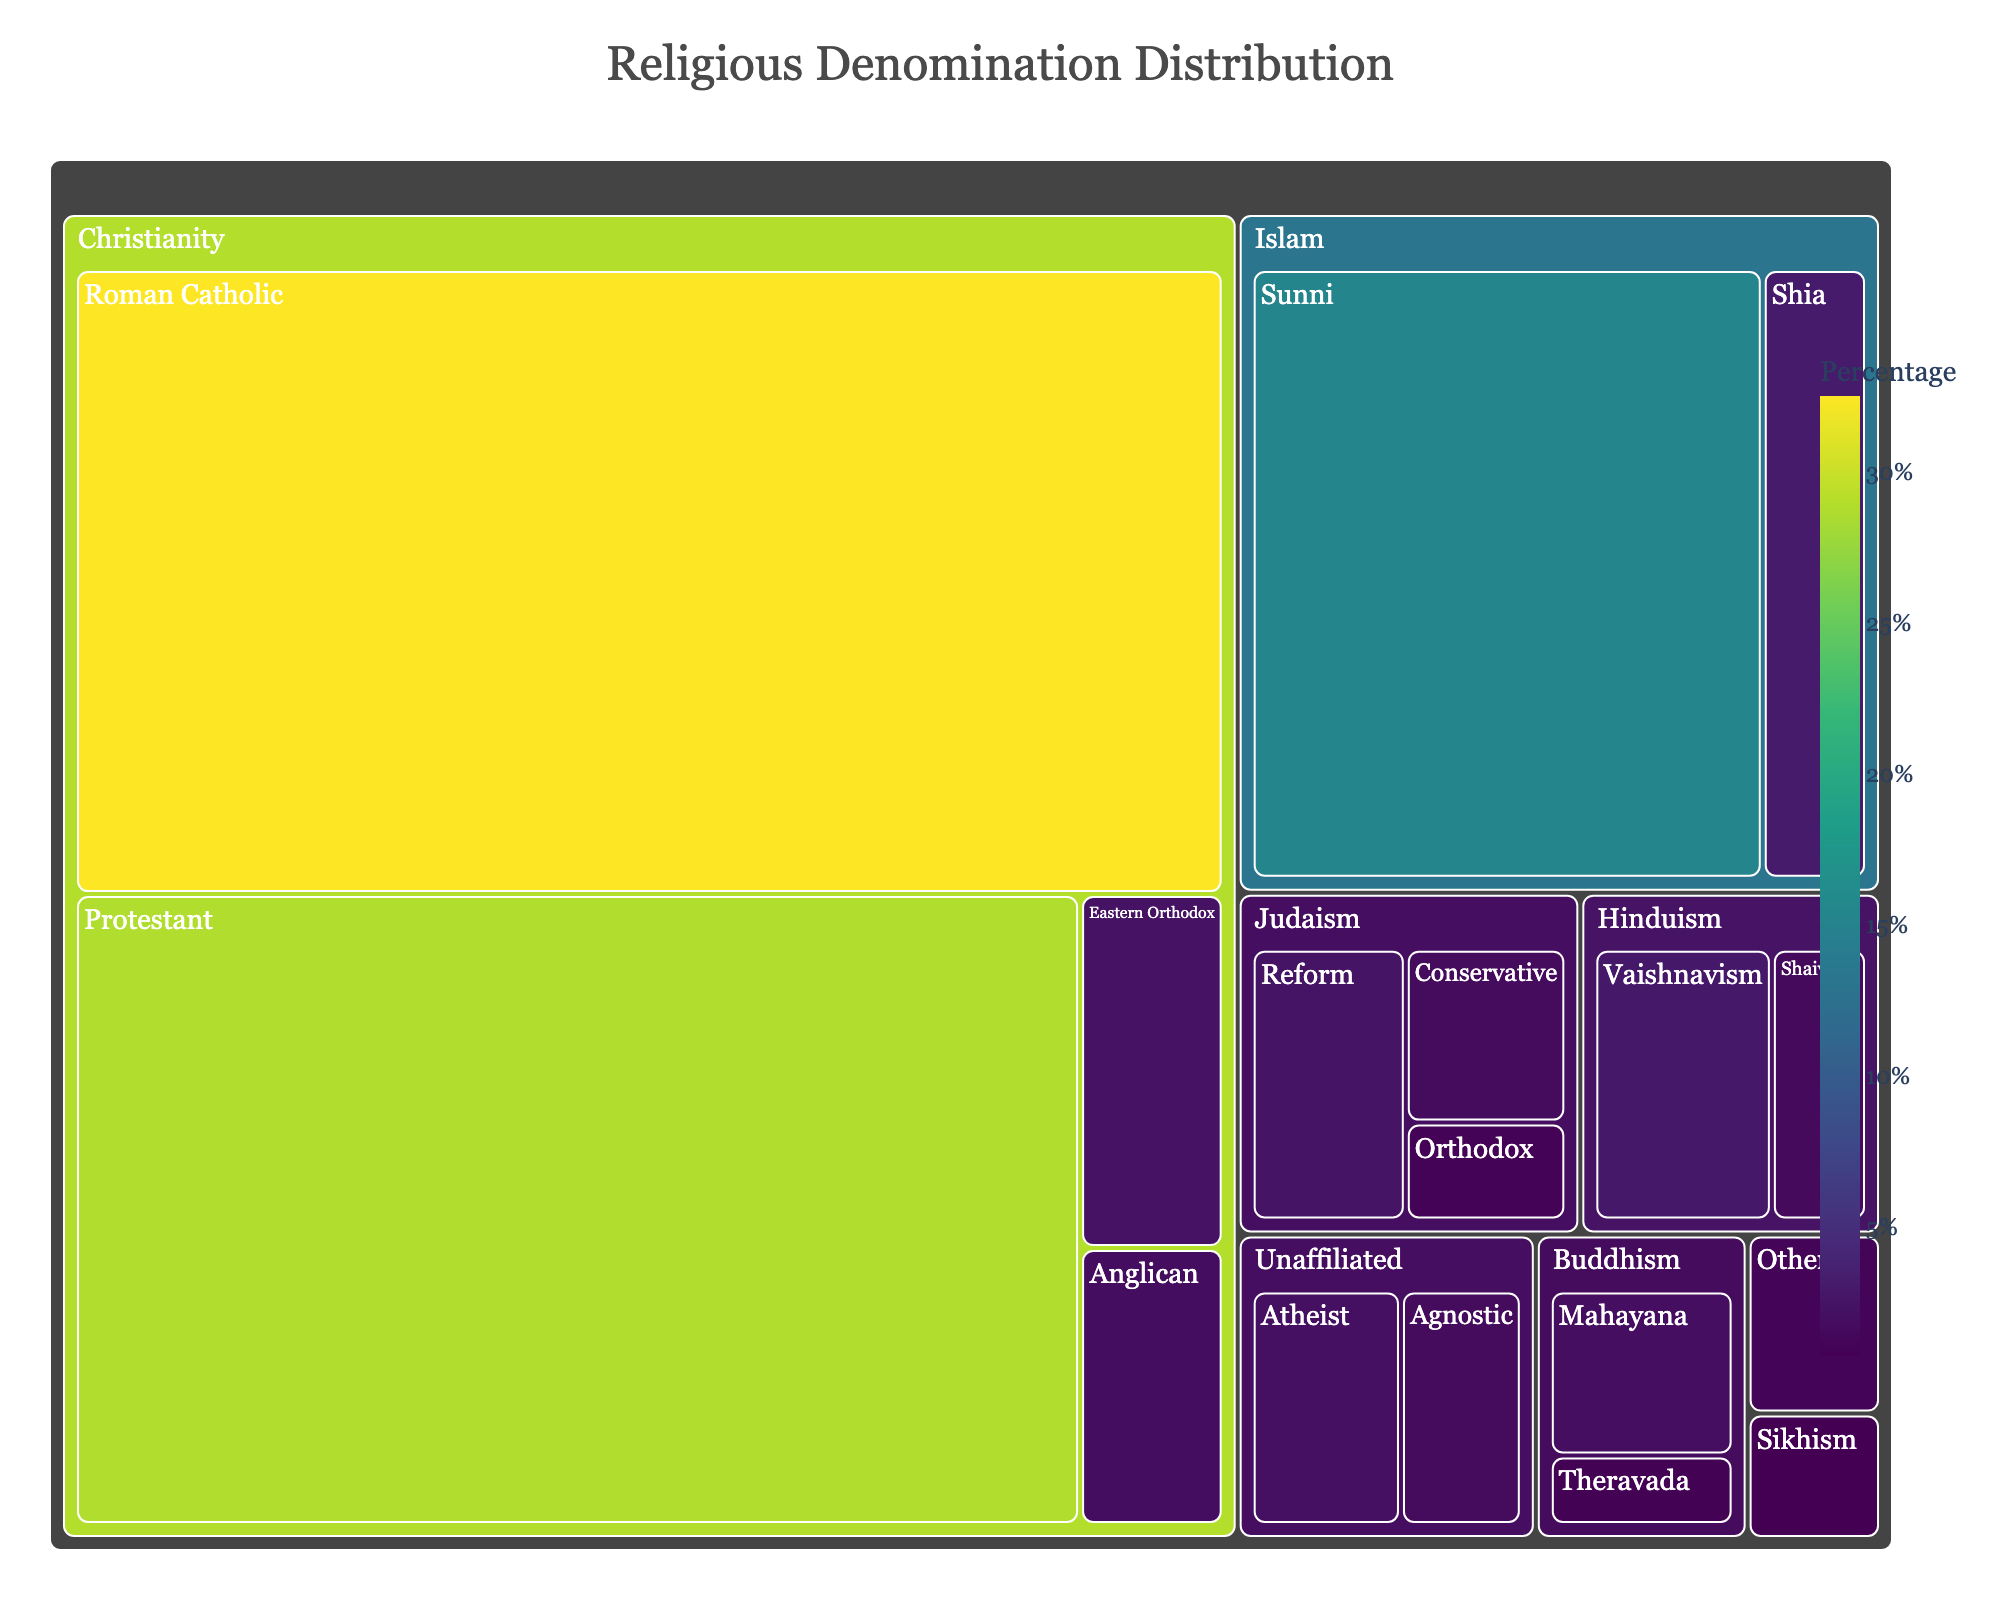What's the largest religious denomination by percentage? By looking at the size of the sections in the Treemap, we can see that Roman Catholic under Christianity has the largest area, which indicates it has the highest percentage.
Answer: Roman Catholic Which religion has the smallest overall representation? In the Treemap, Sikhism and "Other" both have smaller areas, but since Sikhism has the smallest section at 0.7%, it is the least represented.
Answer: Sikhism How do Sunni and Shia Islam's combined percentages compare to Protestant Christianity? The percentages for Sunni (15.2%) and Shia (3.1%) Islam are 15.2 + 3.1 = 18.3%. Protestant Christianity is 28.7%. Comparing these, 18.3% is smaller than 28.7%.
Answer: Sunni and Shia combined are less than Protestant If we sum up the percentages for all denominations within Judaism, what total do we get? Adding up the percentages for Reform (2.4%), Conservative (1.6%), and Orthodox (0.9%) within Judaism: 2.4 + 1.6 + 0.9 = 4.9%.
Answer: 4.9% Which denomination is higher in percentage, Eastern Orthodox Christianity or Mahayana Buddhism? By looking at the Treemap, Eastern Orthodox Christianity has a percentage of 2.3%, while Mahayana Buddhism is at 1.9%. Therefore, Eastern Orthodox is higher.
Answer: Eastern Orthodox Christianity How does the percentage of Unaffiliated (Atheist) compare with Hinduism (Vaishnavism)? The percentage for Atheist is 2.1%, while for Vaishnavism it is 2.8%. Therefore, Vaishnavism has a higher percentage.
Answer: Vaishnavism is higher What is the total percentage of all Christian denominations combined? Adding up the percentages for Roman Catholic (32.5%), Protestant (28.7%), Eastern Orthodox (2.3%), and Anglican (1.8%): 32.5 + 28.7 + 2.3 + 1.8 = 65.3%.
Answer: 65.3% Compare the total percentage of Buddhism to that of Orthodox Judaism. The total percentage for Buddhism (Mahayana and Theravada) is 1.9 + 0.8 = 2.7%. For Orthodox Judaism, it is 0.9%. Thus, Buddhism's total percentage is higher.
Answer: Buddhism is higher What percentage of the population is affiliated with either Hinduism or Sikhism? Adding the percentages of Vaishnavism (2.8%), Shaivism (1.5%), and Sikhism (0.7%): 2.8 + 1.5 + 0.7 = 5.0%.
Answer: 5.0% Which is smaller in percentage, Unaffiliated (Agnostic) or Shia Islam? Comparing the Treemap percentages, Agnostic is 1.7% and Shia Islam is 3.1%. Therefore, Agnostic is smaller.
Answer: Agnostic 